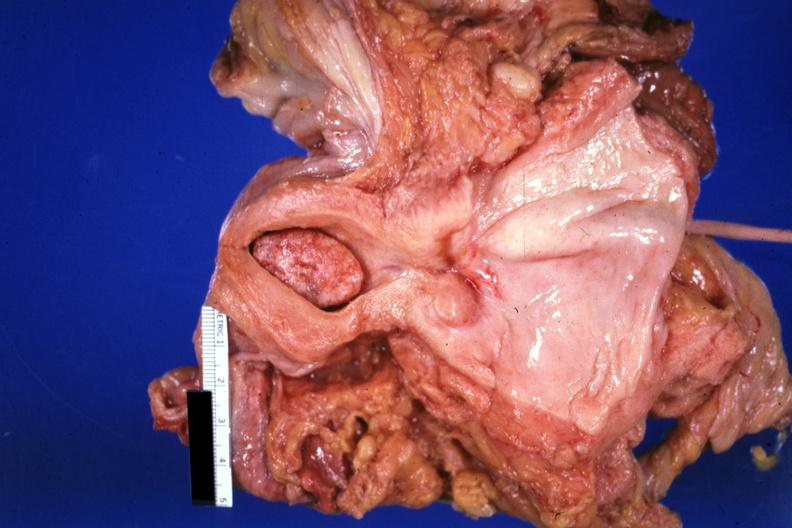does cytomegalovirus show large senile type endometrial polyp?
Answer the question using a single word or phrase. No 